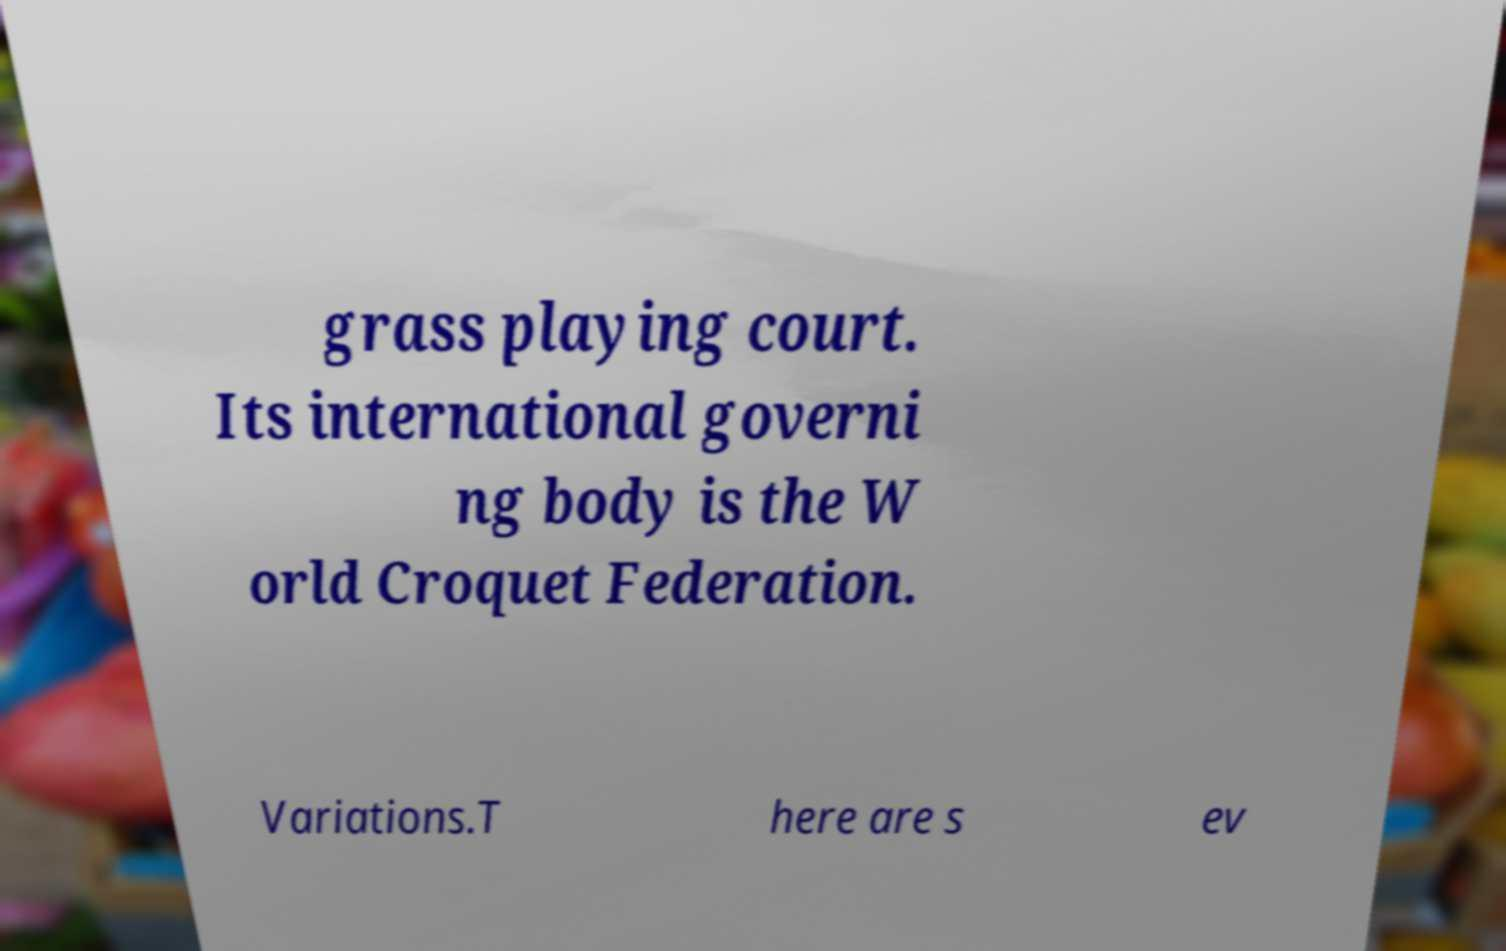For documentation purposes, I need the text within this image transcribed. Could you provide that? grass playing court. Its international governi ng body is the W orld Croquet Federation. Variations.T here are s ev 